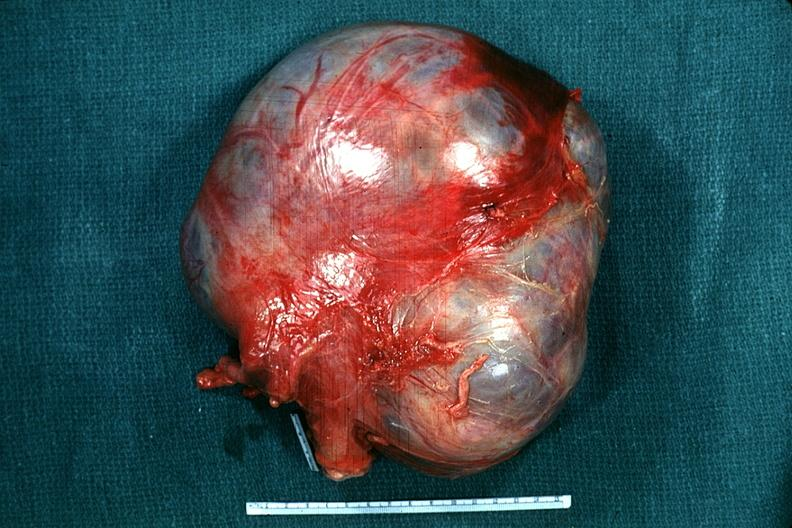what is present?
Answer the question using a single word or phrase. No tissue recognizable as ovary 